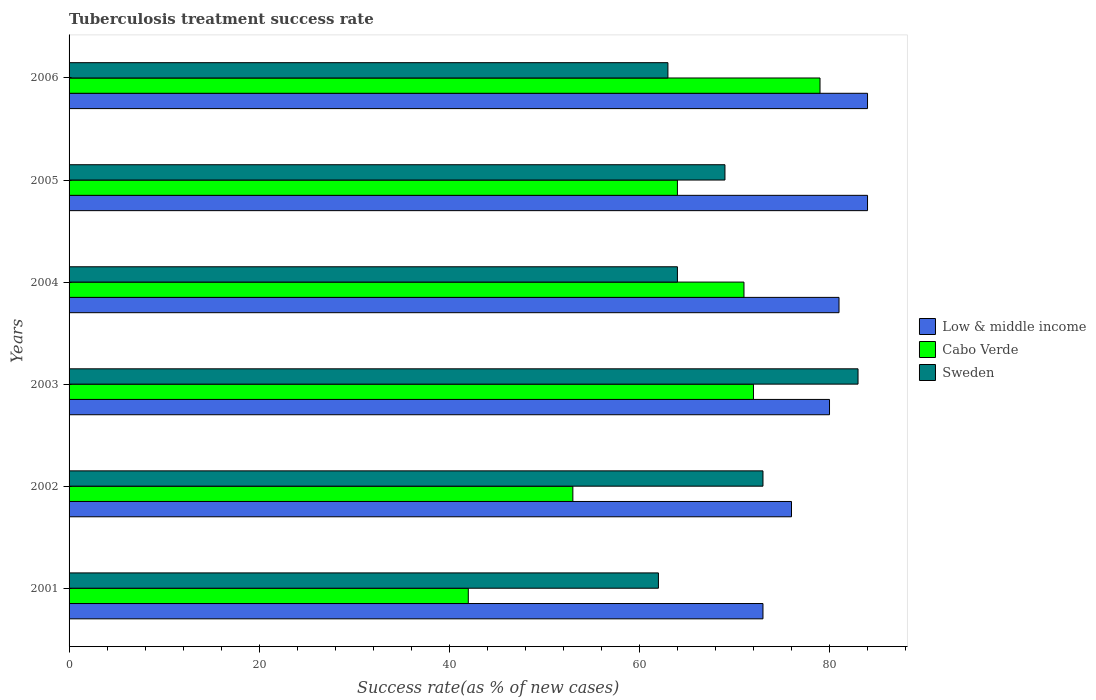How many different coloured bars are there?
Provide a succinct answer. 3. How many bars are there on the 3rd tick from the bottom?
Provide a succinct answer. 3. In how many cases, is the number of bars for a given year not equal to the number of legend labels?
Offer a terse response. 0. What is the tuberculosis treatment success rate in Cabo Verde in 2005?
Your answer should be very brief. 64. Across all years, what is the maximum tuberculosis treatment success rate in Cabo Verde?
Offer a very short reply. 79. Across all years, what is the minimum tuberculosis treatment success rate in Sweden?
Give a very brief answer. 62. In which year was the tuberculosis treatment success rate in Cabo Verde maximum?
Your answer should be compact. 2006. What is the total tuberculosis treatment success rate in Sweden in the graph?
Provide a succinct answer. 414. What is the difference between the tuberculosis treatment success rate in Low & middle income in 2001 and that in 2006?
Provide a succinct answer. -11. What is the difference between the tuberculosis treatment success rate in Cabo Verde in 2004 and the tuberculosis treatment success rate in Low & middle income in 2006?
Offer a very short reply. -13. What is the average tuberculosis treatment success rate in Low & middle income per year?
Your answer should be compact. 79.67. In the year 2006, what is the difference between the tuberculosis treatment success rate in Low & middle income and tuberculosis treatment success rate in Cabo Verde?
Offer a terse response. 5. What is the ratio of the tuberculosis treatment success rate in Cabo Verde in 2002 to that in 2004?
Your answer should be very brief. 0.75. Is the difference between the tuberculosis treatment success rate in Low & middle income in 2001 and 2006 greater than the difference between the tuberculosis treatment success rate in Cabo Verde in 2001 and 2006?
Keep it short and to the point. Yes. What is the difference between the highest and the lowest tuberculosis treatment success rate in Sweden?
Offer a very short reply. 21. Is the sum of the tuberculosis treatment success rate in Sweden in 2002 and 2004 greater than the maximum tuberculosis treatment success rate in Low & middle income across all years?
Offer a very short reply. Yes. What does the 2nd bar from the bottom in 2001 represents?
Provide a succinct answer. Cabo Verde. Is it the case that in every year, the sum of the tuberculosis treatment success rate in Low & middle income and tuberculosis treatment success rate in Cabo Verde is greater than the tuberculosis treatment success rate in Sweden?
Offer a terse response. Yes. How many bars are there?
Make the answer very short. 18. What is the title of the graph?
Provide a succinct answer. Tuberculosis treatment success rate. Does "Bulgaria" appear as one of the legend labels in the graph?
Your answer should be very brief. No. What is the label or title of the X-axis?
Your answer should be compact. Success rate(as % of new cases). What is the Success rate(as % of new cases) of Low & middle income in 2001?
Keep it short and to the point. 73. What is the Success rate(as % of new cases) in Cabo Verde in 2001?
Your answer should be very brief. 42. What is the Success rate(as % of new cases) in Low & middle income in 2002?
Provide a short and direct response. 76. What is the Success rate(as % of new cases) in Cabo Verde in 2002?
Give a very brief answer. 53. What is the Success rate(as % of new cases) in Sweden in 2004?
Your answer should be compact. 64. What is the Success rate(as % of new cases) of Low & middle income in 2006?
Your answer should be compact. 84. What is the Success rate(as % of new cases) of Cabo Verde in 2006?
Provide a succinct answer. 79. What is the Success rate(as % of new cases) in Sweden in 2006?
Keep it short and to the point. 63. Across all years, what is the maximum Success rate(as % of new cases) in Cabo Verde?
Provide a succinct answer. 79. Across all years, what is the maximum Success rate(as % of new cases) of Sweden?
Make the answer very short. 83. Across all years, what is the minimum Success rate(as % of new cases) in Cabo Verde?
Ensure brevity in your answer.  42. What is the total Success rate(as % of new cases) in Low & middle income in the graph?
Your response must be concise. 478. What is the total Success rate(as % of new cases) of Cabo Verde in the graph?
Provide a succinct answer. 381. What is the total Success rate(as % of new cases) of Sweden in the graph?
Your response must be concise. 414. What is the difference between the Success rate(as % of new cases) of Low & middle income in 2001 and that in 2002?
Make the answer very short. -3. What is the difference between the Success rate(as % of new cases) of Cabo Verde in 2001 and that in 2003?
Your answer should be compact. -30. What is the difference between the Success rate(as % of new cases) in Low & middle income in 2001 and that in 2004?
Your answer should be very brief. -8. What is the difference between the Success rate(as % of new cases) of Low & middle income in 2001 and that in 2005?
Offer a very short reply. -11. What is the difference between the Success rate(as % of new cases) of Low & middle income in 2001 and that in 2006?
Ensure brevity in your answer.  -11. What is the difference between the Success rate(as % of new cases) of Cabo Verde in 2001 and that in 2006?
Your response must be concise. -37. What is the difference between the Success rate(as % of new cases) of Cabo Verde in 2002 and that in 2003?
Provide a short and direct response. -19. What is the difference between the Success rate(as % of new cases) of Sweden in 2002 and that in 2003?
Offer a terse response. -10. What is the difference between the Success rate(as % of new cases) in Cabo Verde in 2002 and that in 2004?
Your response must be concise. -18. What is the difference between the Success rate(as % of new cases) in Low & middle income in 2002 and that in 2005?
Make the answer very short. -8. What is the difference between the Success rate(as % of new cases) in Low & middle income in 2002 and that in 2006?
Offer a very short reply. -8. What is the difference between the Success rate(as % of new cases) of Sweden in 2002 and that in 2006?
Your answer should be compact. 10. What is the difference between the Success rate(as % of new cases) in Low & middle income in 2003 and that in 2004?
Ensure brevity in your answer.  -1. What is the difference between the Success rate(as % of new cases) in Low & middle income in 2003 and that in 2005?
Provide a short and direct response. -4. What is the difference between the Success rate(as % of new cases) of Cabo Verde in 2003 and that in 2006?
Your answer should be compact. -7. What is the difference between the Success rate(as % of new cases) in Sweden in 2003 and that in 2006?
Ensure brevity in your answer.  20. What is the difference between the Success rate(as % of new cases) in Sweden in 2004 and that in 2005?
Ensure brevity in your answer.  -5. What is the difference between the Success rate(as % of new cases) in Sweden in 2004 and that in 2006?
Provide a short and direct response. 1. What is the difference between the Success rate(as % of new cases) of Cabo Verde in 2005 and that in 2006?
Keep it short and to the point. -15. What is the difference between the Success rate(as % of new cases) of Sweden in 2005 and that in 2006?
Your response must be concise. 6. What is the difference between the Success rate(as % of new cases) of Cabo Verde in 2001 and the Success rate(as % of new cases) of Sweden in 2002?
Give a very brief answer. -31. What is the difference between the Success rate(as % of new cases) in Low & middle income in 2001 and the Success rate(as % of new cases) in Cabo Verde in 2003?
Your answer should be compact. 1. What is the difference between the Success rate(as % of new cases) of Low & middle income in 2001 and the Success rate(as % of new cases) of Sweden in 2003?
Offer a terse response. -10. What is the difference between the Success rate(as % of new cases) of Cabo Verde in 2001 and the Success rate(as % of new cases) of Sweden in 2003?
Your answer should be very brief. -41. What is the difference between the Success rate(as % of new cases) in Low & middle income in 2001 and the Success rate(as % of new cases) in Sweden in 2005?
Provide a short and direct response. 4. What is the difference between the Success rate(as % of new cases) of Cabo Verde in 2001 and the Success rate(as % of new cases) of Sweden in 2005?
Ensure brevity in your answer.  -27. What is the difference between the Success rate(as % of new cases) of Low & middle income in 2001 and the Success rate(as % of new cases) of Sweden in 2006?
Ensure brevity in your answer.  10. What is the difference between the Success rate(as % of new cases) of Low & middle income in 2002 and the Success rate(as % of new cases) of Sweden in 2004?
Ensure brevity in your answer.  12. What is the difference between the Success rate(as % of new cases) of Cabo Verde in 2002 and the Success rate(as % of new cases) of Sweden in 2004?
Give a very brief answer. -11. What is the difference between the Success rate(as % of new cases) in Low & middle income in 2002 and the Success rate(as % of new cases) in Sweden in 2005?
Your answer should be very brief. 7. What is the difference between the Success rate(as % of new cases) of Cabo Verde in 2002 and the Success rate(as % of new cases) of Sweden in 2005?
Give a very brief answer. -16. What is the difference between the Success rate(as % of new cases) of Low & middle income in 2002 and the Success rate(as % of new cases) of Cabo Verde in 2006?
Ensure brevity in your answer.  -3. What is the difference between the Success rate(as % of new cases) in Cabo Verde in 2002 and the Success rate(as % of new cases) in Sweden in 2006?
Provide a short and direct response. -10. What is the difference between the Success rate(as % of new cases) in Low & middle income in 2003 and the Success rate(as % of new cases) in Cabo Verde in 2005?
Provide a succinct answer. 16. What is the difference between the Success rate(as % of new cases) of Cabo Verde in 2003 and the Success rate(as % of new cases) of Sweden in 2005?
Your answer should be compact. 3. What is the difference between the Success rate(as % of new cases) in Low & middle income in 2003 and the Success rate(as % of new cases) in Cabo Verde in 2006?
Offer a terse response. 1. What is the difference between the Success rate(as % of new cases) in Low & middle income in 2003 and the Success rate(as % of new cases) in Sweden in 2006?
Make the answer very short. 17. What is the difference between the Success rate(as % of new cases) in Low & middle income in 2004 and the Success rate(as % of new cases) in Cabo Verde in 2005?
Make the answer very short. 17. What is the difference between the Success rate(as % of new cases) of Low & middle income in 2004 and the Success rate(as % of new cases) of Sweden in 2005?
Ensure brevity in your answer.  12. What is the difference between the Success rate(as % of new cases) in Low & middle income in 2004 and the Success rate(as % of new cases) in Cabo Verde in 2006?
Keep it short and to the point. 2. What is the difference between the Success rate(as % of new cases) of Cabo Verde in 2004 and the Success rate(as % of new cases) of Sweden in 2006?
Offer a terse response. 8. What is the average Success rate(as % of new cases) of Low & middle income per year?
Provide a short and direct response. 79.67. What is the average Success rate(as % of new cases) of Cabo Verde per year?
Your response must be concise. 63.5. What is the average Success rate(as % of new cases) in Sweden per year?
Your answer should be very brief. 69. In the year 2001, what is the difference between the Success rate(as % of new cases) of Low & middle income and Success rate(as % of new cases) of Cabo Verde?
Keep it short and to the point. 31. In the year 2002, what is the difference between the Success rate(as % of new cases) in Cabo Verde and Success rate(as % of new cases) in Sweden?
Your answer should be very brief. -20. In the year 2003, what is the difference between the Success rate(as % of new cases) of Low & middle income and Success rate(as % of new cases) of Sweden?
Provide a short and direct response. -3. In the year 2004, what is the difference between the Success rate(as % of new cases) of Low & middle income and Success rate(as % of new cases) of Sweden?
Your response must be concise. 17. In the year 2004, what is the difference between the Success rate(as % of new cases) of Cabo Verde and Success rate(as % of new cases) of Sweden?
Offer a very short reply. 7. In the year 2005, what is the difference between the Success rate(as % of new cases) in Cabo Verde and Success rate(as % of new cases) in Sweden?
Your response must be concise. -5. In the year 2006, what is the difference between the Success rate(as % of new cases) of Low & middle income and Success rate(as % of new cases) of Cabo Verde?
Provide a short and direct response. 5. In the year 2006, what is the difference between the Success rate(as % of new cases) of Cabo Verde and Success rate(as % of new cases) of Sweden?
Your answer should be very brief. 16. What is the ratio of the Success rate(as % of new cases) of Low & middle income in 2001 to that in 2002?
Ensure brevity in your answer.  0.96. What is the ratio of the Success rate(as % of new cases) in Cabo Verde in 2001 to that in 2002?
Make the answer very short. 0.79. What is the ratio of the Success rate(as % of new cases) of Sweden in 2001 to that in 2002?
Your answer should be very brief. 0.85. What is the ratio of the Success rate(as % of new cases) in Low & middle income in 2001 to that in 2003?
Offer a very short reply. 0.91. What is the ratio of the Success rate(as % of new cases) in Cabo Verde in 2001 to that in 2003?
Ensure brevity in your answer.  0.58. What is the ratio of the Success rate(as % of new cases) of Sweden in 2001 to that in 2003?
Your response must be concise. 0.75. What is the ratio of the Success rate(as % of new cases) of Low & middle income in 2001 to that in 2004?
Provide a succinct answer. 0.9. What is the ratio of the Success rate(as % of new cases) in Cabo Verde in 2001 to that in 2004?
Your answer should be very brief. 0.59. What is the ratio of the Success rate(as % of new cases) in Sweden in 2001 to that in 2004?
Offer a terse response. 0.97. What is the ratio of the Success rate(as % of new cases) of Low & middle income in 2001 to that in 2005?
Make the answer very short. 0.87. What is the ratio of the Success rate(as % of new cases) in Cabo Verde in 2001 to that in 2005?
Your answer should be very brief. 0.66. What is the ratio of the Success rate(as % of new cases) in Sweden in 2001 to that in 2005?
Offer a terse response. 0.9. What is the ratio of the Success rate(as % of new cases) of Low & middle income in 2001 to that in 2006?
Your answer should be very brief. 0.87. What is the ratio of the Success rate(as % of new cases) in Cabo Verde in 2001 to that in 2006?
Your answer should be very brief. 0.53. What is the ratio of the Success rate(as % of new cases) of Sweden in 2001 to that in 2006?
Your answer should be compact. 0.98. What is the ratio of the Success rate(as % of new cases) in Cabo Verde in 2002 to that in 2003?
Provide a succinct answer. 0.74. What is the ratio of the Success rate(as % of new cases) in Sweden in 2002 to that in 2003?
Keep it short and to the point. 0.88. What is the ratio of the Success rate(as % of new cases) of Low & middle income in 2002 to that in 2004?
Provide a short and direct response. 0.94. What is the ratio of the Success rate(as % of new cases) of Cabo Verde in 2002 to that in 2004?
Make the answer very short. 0.75. What is the ratio of the Success rate(as % of new cases) in Sweden in 2002 to that in 2004?
Make the answer very short. 1.14. What is the ratio of the Success rate(as % of new cases) in Low & middle income in 2002 to that in 2005?
Provide a succinct answer. 0.9. What is the ratio of the Success rate(as % of new cases) of Cabo Verde in 2002 to that in 2005?
Your answer should be very brief. 0.83. What is the ratio of the Success rate(as % of new cases) in Sweden in 2002 to that in 2005?
Your response must be concise. 1.06. What is the ratio of the Success rate(as % of new cases) of Low & middle income in 2002 to that in 2006?
Offer a terse response. 0.9. What is the ratio of the Success rate(as % of new cases) of Cabo Verde in 2002 to that in 2006?
Your answer should be very brief. 0.67. What is the ratio of the Success rate(as % of new cases) in Sweden in 2002 to that in 2006?
Give a very brief answer. 1.16. What is the ratio of the Success rate(as % of new cases) of Low & middle income in 2003 to that in 2004?
Make the answer very short. 0.99. What is the ratio of the Success rate(as % of new cases) of Cabo Verde in 2003 to that in 2004?
Keep it short and to the point. 1.01. What is the ratio of the Success rate(as % of new cases) in Sweden in 2003 to that in 2004?
Offer a very short reply. 1.3. What is the ratio of the Success rate(as % of new cases) of Cabo Verde in 2003 to that in 2005?
Your answer should be compact. 1.12. What is the ratio of the Success rate(as % of new cases) in Sweden in 2003 to that in 2005?
Ensure brevity in your answer.  1.2. What is the ratio of the Success rate(as % of new cases) in Cabo Verde in 2003 to that in 2006?
Provide a succinct answer. 0.91. What is the ratio of the Success rate(as % of new cases) in Sweden in 2003 to that in 2006?
Ensure brevity in your answer.  1.32. What is the ratio of the Success rate(as % of new cases) in Cabo Verde in 2004 to that in 2005?
Your answer should be very brief. 1.11. What is the ratio of the Success rate(as % of new cases) in Sweden in 2004 to that in 2005?
Offer a very short reply. 0.93. What is the ratio of the Success rate(as % of new cases) in Low & middle income in 2004 to that in 2006?
Keep it short and to the point. 0.96. What is the ratio of the Success rate(as % of new cases) of Cabo Verde in 2004 to that in 2006?
Give a very brief answer. 0.9. What is the ratio of the Success rate(as % of new cases) in Sweden in 2004 to that in 2006?
Make the answer very short. 1.02. What is the ratio of the Success rate(as % of new cases) in Low & middle income in 2005 to that in 2006?
Give a very brief answer. 1. What is the ratio of the Success rate(as % of new cases) in Cabo Verde in 2005 to that in 2006?
Give a very brief answer. 0.81. What is the ratio of the Success rate(as % of new cases) in Sweden in 2005 to that in 2006?
Ensure brevity in your answer.  1.1. What is the difference between the highest and the second highest Success rate(as % of new cases) of Low & middle income?
Offer a very short reply. 0. What is the difference between the highest and the lowest Success rate(as % of new cases) of Low & middle income?
Offer a terse response. 11. What is the difference between the highest and the lowest Success rate(as % of new cases) in Cabo Verde?
Ensure brevity in your answer.  37. 